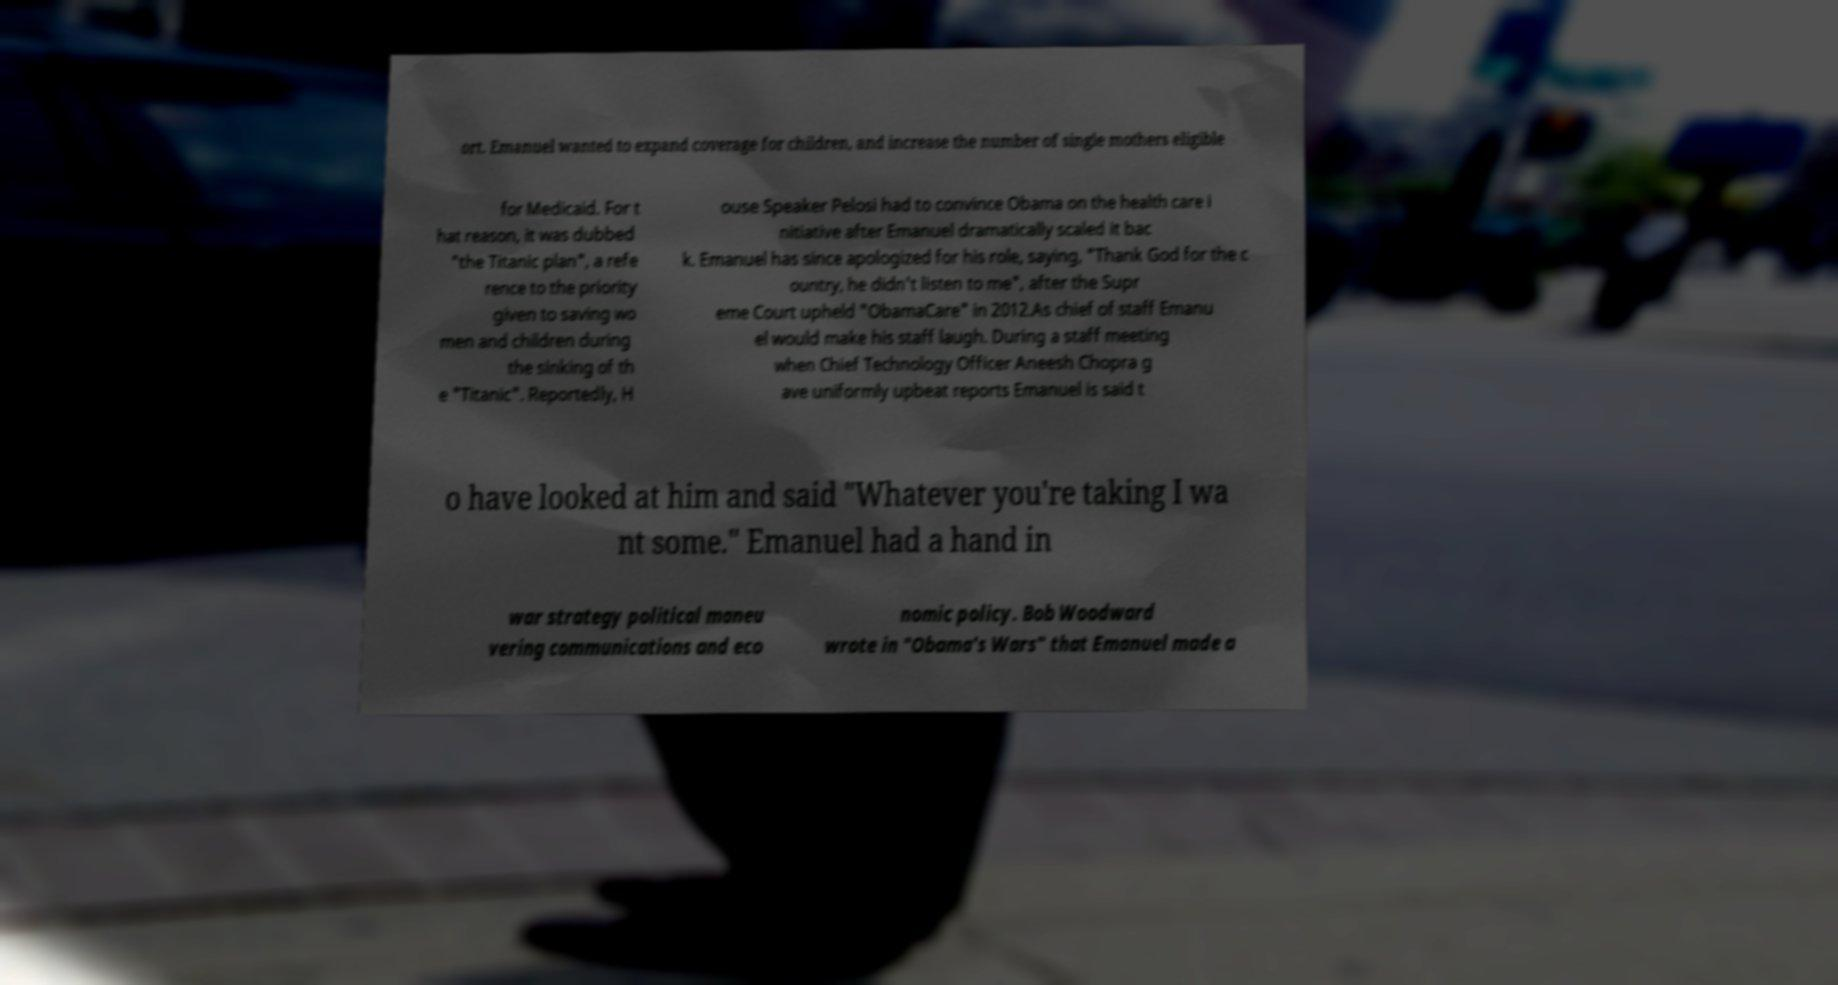For documentation purposes, I need the text within this image transcribed. Could you provide that? ort. Emanuel wanted to expand coverage for children, and increase the number of single mothers eligible for Medicaid. For t hat reason, it was dubbed "the Titanic plan", a refe rence to the priority given to saving wo men and children during the sinking of th e "Titanic". Reportedly, H ouse Speaker Pelosi had to convince Obama on the health care i nitiative after Emanuel dramatically scaled it bac k. Emanuel has since apologized for his role, saying, "Thank God for the c ountry, he didn't listen to me", after the Supr eme Court upheld "ObamaCare" in 2012.As chief of staff Emanu el would make his staff laugh. During a staff meeting when Chief Technology Officer Aneesh Chopra g ave uniformly upbeat reports Emanuel is said t o have looked at him and said "Whatever you're taking I wa nt some." Emanuel had a hand in war strategy political maneu vering communications and eco nomic policy. Bob Woodward wrote in "Obama's Wars" that Emanuel made a 